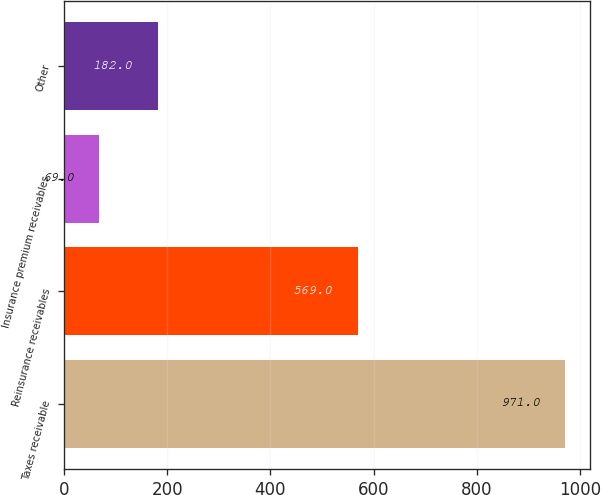Convert chart. <chart><loc_0><loc_0><loc_500><loc_500><bar_chart><fcel>Taxes receivable<fcel>Reinsurance receivables<fcel>Insurance premium receivables<fcel>Other<nl><fcel>971<fcel>569<fcel>69<fcel>182<nl></chart> 